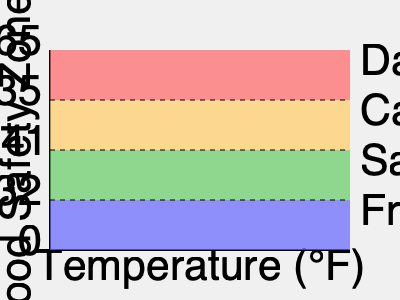According to the food safety temperature chart, what is the temperature range of the "Danger Zone" where bacteria grow most rapidly, and what immediate action should be taken if food is found in this zone? To answer this question, let's analyze the food safety temperature chart step-by-step:

1. The chart is divided into four zones, from top to bottom:
   - Red zone: Danger Zone
   - Orange zone: Caution Zone
   - Green zone: Safe Zone
   - Blue zone: Freezing Zone

2. Each zone is associated with a temperature range:
   - Danger Zone: 135°F to 165°F
   - Caution Zone: 41°F to 135°F
   - Safe Zone: 32°F to 41°F
   - Freezing Zone: 0°F to 32°F

3. The question specifically asks about the "Danger Zone":
   - The Danger Zone is represented by the red area at the top of the chart.
   - It ranges from 135°F to 165°F.

4. The Danger Zone is where bacteria grow most rapidly, posing a significant food safety risk.

5. When food is found in the Danger Zone, immediate action should be taken to either:
   a) Quickly cool the food below 41°F if it's meant to be cold, or
   b) Rapidly heat the food above 165°F if it's meant to be hot.

6. The goal is to minimize the time food spends in the Danger Zone to prevent bacterial growth and potential foodborne illness.
Answer: 135°F to 165°F; quickly cool below 41°F or heat above 165°F. 